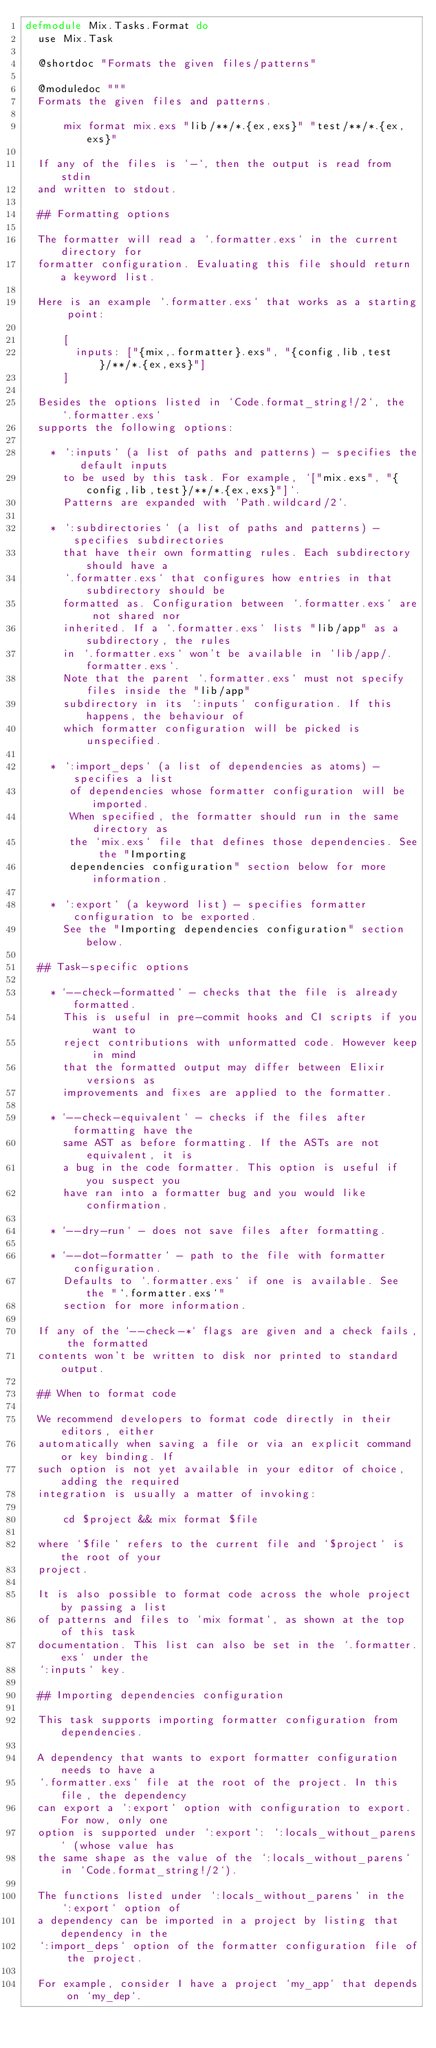Convert code to text. <code><loc_0><loc_0><loc_500><loc_500><_Elixir_>defmodule Mix.Tasks.Format do
  use Mix.Task

  @shortdoc "Formats the given files/patterns"

  @moduledoc """
  Formats the given files and patterns.

      mix format mix.exs "lib/**/*.{ex,exs}" "test/**/*.{ex,exs}"

  If any of the files is `-`, then the output is read from stdin
  and written to stdout.

  ## Formatting options

  The formatter will read a `.formatter.exs` in the current directory for
  formatter configuration. Evaluating this file should return a keyword list.

  Here is an example `.formatter.exs` that works as a starting point:

      [
        inputs: ["{mix,.formatter}.exs", "{config,lib,test}/**/*.{ex,exs}"]
      ]

  Besides the options listed in `Code.format_string!/2`, the `.formatter.exs`
  supports the following options:

    * `:inputs` (a list of paths and patterns) - specifies the default inputs
      to be used by this task. For example, `["mix.exs", "{config,lib,test}/**/*.{ex,exs}"]`.
      Patterns are expanded with `Path.wildcard/2`.

    * `:subdirectories` (a list of paths and patterns) - specifies subdirectories
      that have their own formatting rules. Each subdirectory should have a
      `.formatter.exs` that configures how entries in that subdirectory should be
      formatted as. Configuration between `.formatter.exs` are not shared nor
      inherited. If a `.formatter.exs` lists "lib/app" as a subdirectory, the rules
      in `.formatter.exs` won't be available in `lib/app/.formatter.exs`.
      Note that the parent `.formatter.exs` must not specify files inside the "lib/app"
      subdirectory in its `:inputs` configuration. If this happens, the behaviour of
      which formatter configuration will be picked is unspecified.

    * `:import_deps` (a list of dependencies as atoms) - specifies a list
       of dependencies whose formatter configuration will be imported.
       When specified, the formatter should run in the same directory as
       the `mix.exs` file that defines those dependencies. See the "Importing
       dependencies configuration" section below for more information.

    * `:export` (a keyword list) - specifies formatter configuration to be exported.
      See the "Importing dependencies configuration" section below.

  ## Task-specific options

    * `--check-formatted` - checks that the file is already formatted.
      This is useful in pre-commit hooks and CI scripts if you want to
      reject contributions with unformatted code. However keep in mind
      that the formatted output may differ between Elixir versions as
      improvements and fixes are applied to the formatter.

    * `--check-equivalent` - checks if the files after formatting have the
      same AST as before formatting. If the ASTs are not equivalent, it is
      a bug in the code formatter. This option is useful if you suspect you
      have ran into a formatter bug and you would like confirmation.

    * `--dry-run` - does not save files after formatting.

    * `--dot-formatter` - path to the file with formatter configuration.
      Defaults to `.formatter.exs` if one is available. See the "`.formatter.exs`"
      section for more information.

  If any of the `--check-*` flags are given and a check fails, the formatted
  contents won't be written to disk nor printed to standard output.

  ## When to format code

  We recommend developers to format code directly in their editors, either
  automatically when saving a file or via an explicit command or key binding. If
  such option is not yet available in your editor of choice, adding the required
  integration is usually a matter of invoking:

      cd $project && mix format $file

  where `$file` refers to the current file and `$project` is the root of your
  project.

  It is also possible to format code across the whole project by passing a list
  of patterns and files to `mix format`, as shown at the top of this task
  documentation. This list can also be set in the `.formatter.exs` under the
  `:inputs` key.

  ## Importing dependencies configuration

  This task supports importing formatter configuration from dependencies.

  A dependency that wants to export formatter configuration needs to have a
  `.formatter.exs` file at the root of the project. In this file, the dependency
  can export a `:export` option with configuration to export. For now, only one
  option is supported under `:export`: `:locals_without_parens` (whose value has
  the same shape as the value of the `:locals_without_parens` in `Code.format_string!/2`).

  The functions listed under `:locals_without_parens` in the `:export` option of
  a dependency can be imported in a project by listing that dependency in the
  `:import_deps` option of the formatter configuration file of the project.

  For example, consider I have a project `my_app` that depends on `my_dep`.</code> 